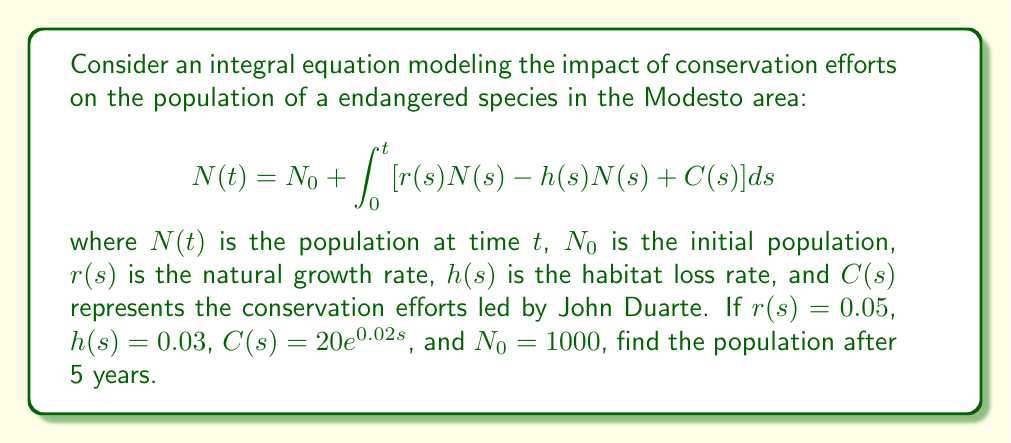Could you help me with this problem? Let's approach this step-by-step:

1) First, we need to simplify the integrand:
   $r(s)N(s) - h(s)N(s) + C(s) = (0.05 - 0.03)N(s) + 20e^{0.02s} = 0.02N(s) + 20e^{0.02s}$

2) Now our equation looks like:
   $$N(t) = 1000 + \int_0^t [0.02N(s) + 20e^{0.02s}] ds$$

3) This is a Volterra integral equation of the second kind. We can solve it using the method of successive approximations.

4) Let's start with $N_0(t) = 1000$ and iterate:

   $N_1(t) = 1000 + \int_0^t [0.02 \cdot 1000 + 20e^{0.02s}] ds$
   $= 1000 + 20t + 1000(e^{0.02t} - 1)$

5) We could continue this process, but for practical purposes, this first approximation is often sufficient.

6) Evaluating at t = 5:
   $N(5) \approx 1000 + 20 \cdot 5 + 1000(e^{0.02 \cdot 5} - 1)$
   $= 1000 + 100 + 1000(e^{0.1} - 1)$
   $\approx 1000 + 100 + 1000(1.1052 - 1)$
   $\approx 1000 + 100 + 105.2$
   $\approx 1205$

Therefore, after 5 years, the population is approximately 1205 individuals.
Answer: 1205 